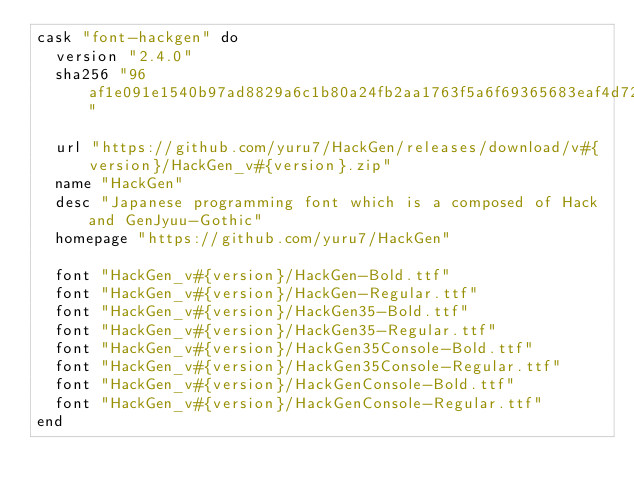<code> <loc_0><loc_0><loc_500><loc_500><_Ruby_>cask "font-hackgen" do
  version "2.4.0"
  sha256 "96af1e091e1540b97ad8829a6c1b80a24fb2aa1763f5a6f69365683eaf4d7220"

  url "https://github.com/yuru7/HackGen/releases/download/v#{version}/HackGen_v#{version}.zip"
  name "HackGen"
  desc "Japanese programming font which is a composed of Hack and GenJyuu-Gothic"
  homepage "https://github.com/yuru7/HackGen"

  font "HackGen_v#{version}/HackGen-Bold.ttf"
  font "HackGen_v#{version}/HackGen-Regular.ttf"
  font "HackGen_v#{version}/HackGen35-Bold.ttf"
  font "HackGen_v#{version}/HackGen35-Regular.ttf"
  font "HackGen_v#{version}/HackGen35Console-Bold.ttf"
  font "HackGen_v#{version}/HackGen35Console-Regular.ttf"
  font "HackGen_v#{version}/HackGenConsole-Bold.ttf"
  font "HackGen_v#{version}/HackGenConsole-Regular.ttf"
end
</code> 